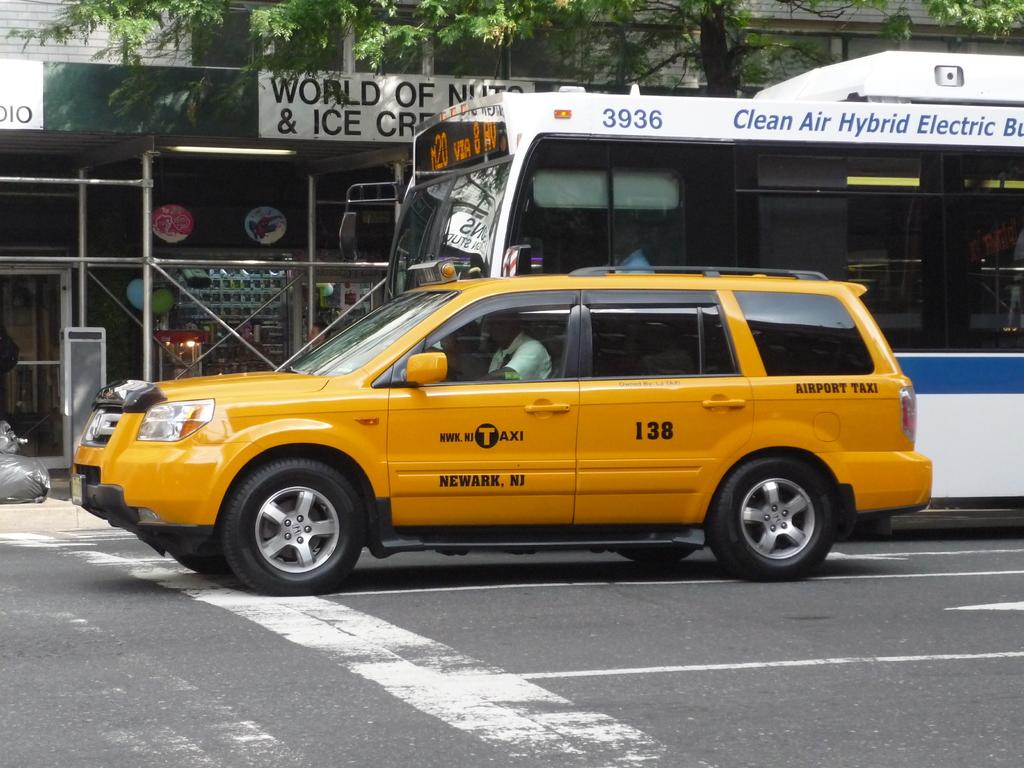<image>
Write a terse but informative summary of the picture. A taxi is sitting next to to a public bus on the street. 